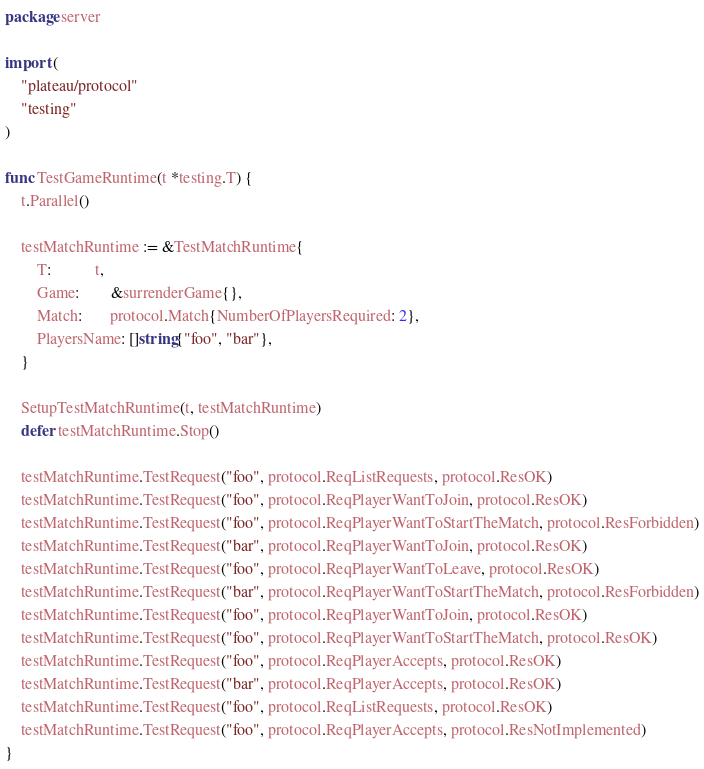Convert code to text. <code><loc_0><loc_0><loc_500><loc_500><_Go_>package server

import (
	"plateau/protocol"
	"testing"
)

func TestGameRuntime(t *testing.T) {
	t.Parallel()

	testMatchRuntime := &TestMatchRuntime{
		T:           t,
		Game:        &surrenderGame{},
		Match:       protocol.Match{NumberOfPlayersRequired: 2},
		PlayersName: []string{"foo", "bar"},
	}

	SetupTestMatchRuntime(t, testMatchRuntime)
	defer testMatchRuntime.Stop()

	testMatchRuntime.TestRequest("foo", protocol.ReqListRequests, protocol.ResOK)
	testMatchRuntime.TestRequest("foo", protocol.ReqPlayerWantToJoin, protocol.ResOK)
	testMatchRuntime.TestRequest("foo", protocol.ReqPlayerWantToStartTheMatch, protocol.ResForbidden)
	testMatchRuntime.TestRequest("bar", protocol.ReqPlayerWantToJoin, protocol.ResOK)
	testMatchRuntime.TestRequest("foo", protocol.ReqPlayerWantToLeave, protocol.ResOK)
	testMatchRuntime.TestRequest("bar", protocol.ReqPlayerWantToStartTheMatch, protocol.ResForbidden)
	testMatchRuntime.TestRequest("foo", protocol.ReqPlayerWantToJoin, protocol.ResOK)
	testMatchRuntime.TestRequest("foo", protocol.ReqPlayerWantToStartTheMatch, protocol.ResOK)
	testMatchRuntime.TestRequest("foo", protocol.ReqPlayerAccepts, protocol.ResOK)
	testMatchRuntime.TestRequest("bar", protocol.ReqPlayerAccepts, protocol.ResOK)
	testMatchRuntime.TestRequest("foo", protocol.ReqListRequests, protocol.ResOK)
	testMatchRuntime.TestRequest("foo", protocol.ReqPlayerAccepts, protocol.ResNotImplemented)
}
</code> 